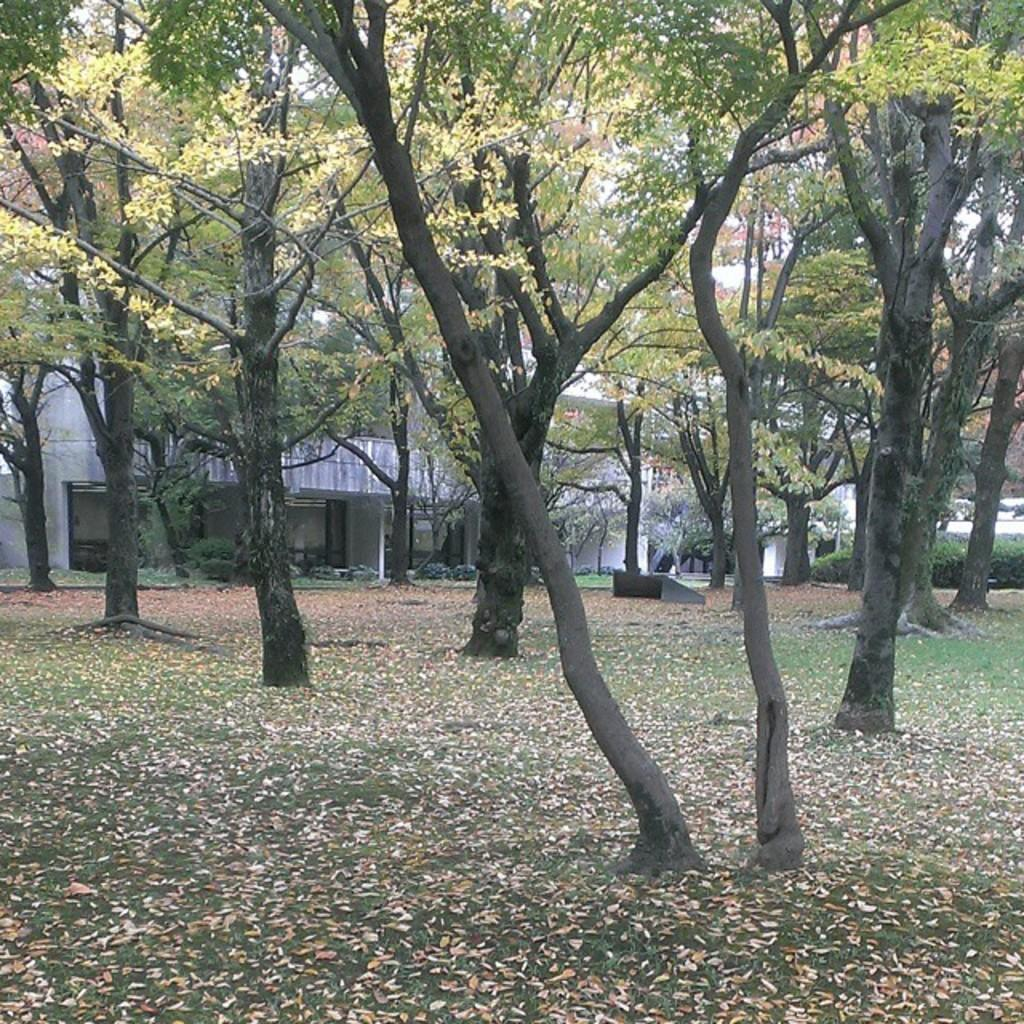What type of vegetation can be seen in the image? There is a group of trees and plants present in the image. What structure is visible behind the trees? There is a building visible behind the trees. What is covering the surface at the bottom of the image? Leaves are visible on the surface at the bottom of the image. What type of oil can be seen dripping from the leaves in the image? There is no oil present in the image; only leaves are visible on the surface at the bottom of the image. 